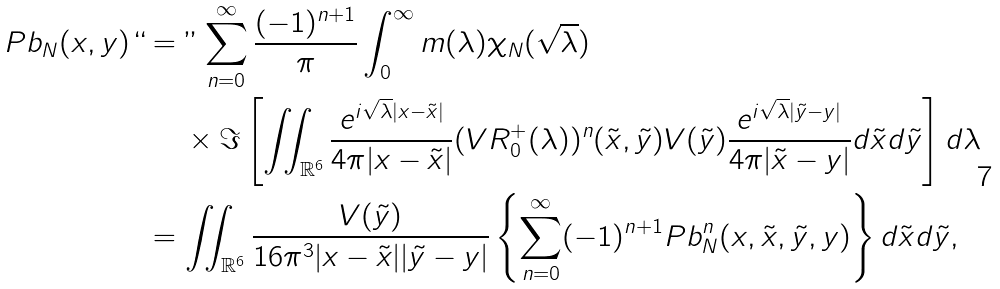<formula> <loc_0><loc_0><loc_500><loc_500>P b _ { N } ( x , y ) ` ` & = " \sum _ { n = 0 } ^ { \infty } \frac { ( - 1 ) ^ { n + 1 } } { \pi } \int _ { 0 } ^ { \infty } m ( \lambda ) \chi _ { N } ( \sqrt { \lambda } ) \\ & \quad \ \times \Im \left [ \iint _ { \mathbb { R } ^ { 6 } } \frac { e ^ { i \sqrt { \lambda } | x - \tilde { x } | } } { 4 \pi | x - \tilde { x } | } ( V R _ { 0 } ^ { + } ( \lambda ) ) ^ { n } ( \tilde { x } , \tilde { y } ) V ( \tilde { y } ) \frac { e ^ { i \sqrt { \lambda } | \tilde { y } - y | } } { 4 \pi | \tilde { x } - y | } d \tilde { x } d \tilde { y } \right ] d \lambda \\ & = \iint _ { \mathbb { R } ^ { 6 } } \frac { V ( \tilde { y } ) } { 1 6 \pi ^ { 3 } | x - \tilde { x } | | \tilde { y } - y | } \left \{ \sum _ { n = 0 } ^ { \infty } ( - 1 ) ^ { n + 1 } P b _ { N } ^ { n } ( x , \tilde { x } , \tilde { y } , y ) \right \} d \tilde { x } d \tilde { y } ,</formula> 